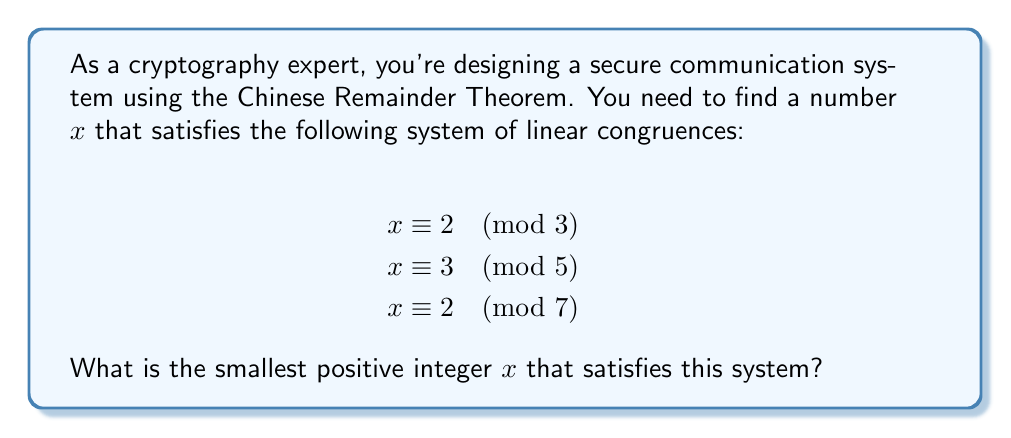Give your solution to this math problem. To solve this system using the Chinese Remainder Theorem:

1) First, calculate $M = 3 \times 5 \times 7 = 105$

2) For each congruence, calculate $M_i = M / m_i$:
   $M_1 = 105 / 3 = 35$
   $M_2 = 105 / 5 = 21$
   $M_3 = 105 / 7 = 15$

3) Find the modular multiplicative inverses:
   $35^{-1} \equiv 2 \pmod{3}$
   $21^{-1} \equiv 1 \pmod{5}$
   $15^{-1} \equiv 1 \pmod{7}$

4) Calculate the solution:
   $x = (2 \times 35 \times 2 + 3 \times 21 \times 1 + 2 \times 15 \times 1) \pmod{105}$
   $x = (140 + 63 + 30) \pmod{105}$
   $x = 233 \pmod{105}$
   $x = 23$

5) Verify the solution:
   $23 \equiv 2 \pmod{3}$
   $23 \equiv 3 \pmod{5}$
   $23 \equiv 2 \pmod{7}$

Therefore, the smallest positive integer $x$ that satisfies the system is 23.
Answer: 23 